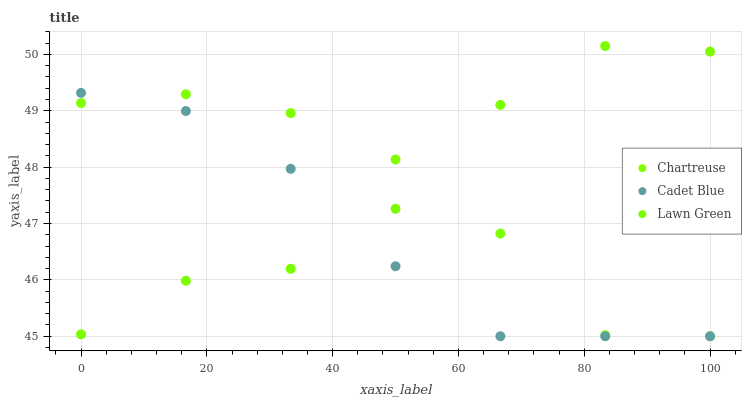Does Cadet Blue have the minimum area under the curve?
Answer yes or no. Yes. Does Lawn Green have the maximum area under the curve?
Answer yes or no. Yes. Does Chartreuse have the minimum area under the curve?
Answer yes or no. No. Does Chartreuse have the maximum area under the curve?
Answer yes or no. No. Is Cadet Blue the smoothest?
Answer yes or no. Yes. Is Lawn Green the roughest?
Answer yes or no. Yes. Is Chartreuse the smoothest?
Answer yes or no. No. Is Chartreuse the roughest?
Answer yes or no. No. Does Chartreuse have the lowest value?
Answer yes or no. Yes. Does Lawn Green have the highest value?
Answer yes or no. Yes. Does Cadet Blue have the highest value?
Answer yes or no. No. Does Cadet Blue intersect Lawn Green?
Answer yes or no. Yes. Is Cadet Blue less than Lawn Green?
Answer yes or no. No. Is Cadet Blue greater than Lawn Green?
Answer yes or no. No. 